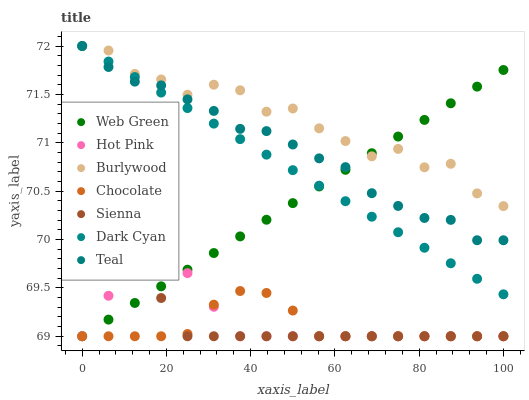Does Chocolate have the minimum area under the curve?
Answer yes or no. Yes. Does Burlywood have the maximum area under the curve?
Answer yes or no. Yes. Does Hot Pink have the minimum area under the curve?
Answer yes or no. No. Does Hot Pink have the maximum area under the curve?
Answer yes or no. No. Is Dark Cyan the smoothest?
Answer yes or no. Yes. Is Burlywood the roughest?
Answer yes or no. Yes. Is Hot Pink the smoothest?
Answer yes or no. No. Is Hot Pink the roughest?
Answer yes or no. No. Does Hot Pink have the lowest value?
Answer yes or no. Yes. Does Teal have the lowest value?
Answer yes or no. No. Does Dark Cyan have the highest value?
Answer yes or no. Yes. Does Hot Pink have the highest value?
Answer yes or no. No. Is Hot Pink less than Teal?
Answer yes or no. Yes. Is Dark Cyan greater than Chocolate?
Answer yes or no. Yes. Does Sienna intersect Web Green?
Answer yes or no. Yes. Is Sienna less than Web Green?
Answer yes or no. No. Is Sienna greater than Web Green?
Answer yes or no. No. Does Hot Pink intersect Teal?
Answer yes or no. No. 